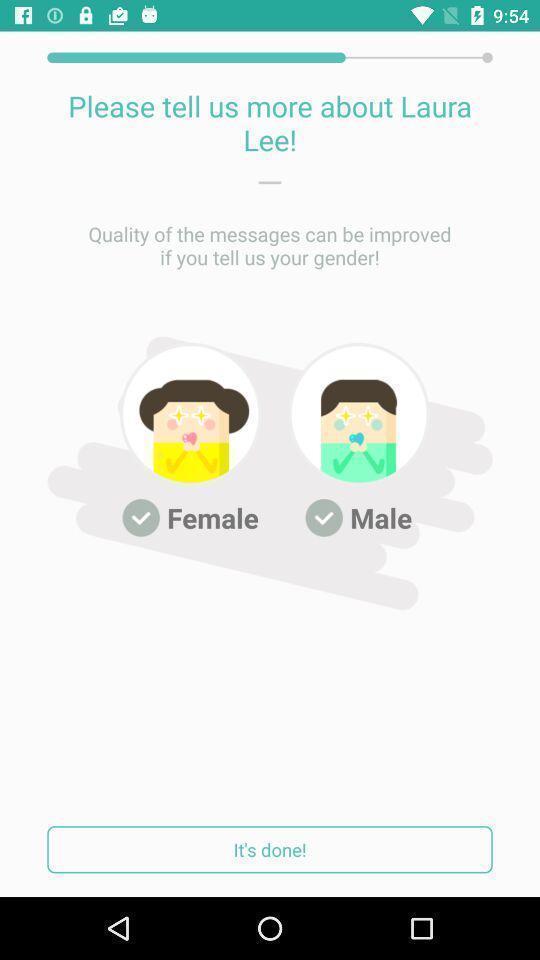Explain what's happening in this screen capture. Registration page asking to select gender in social app. 